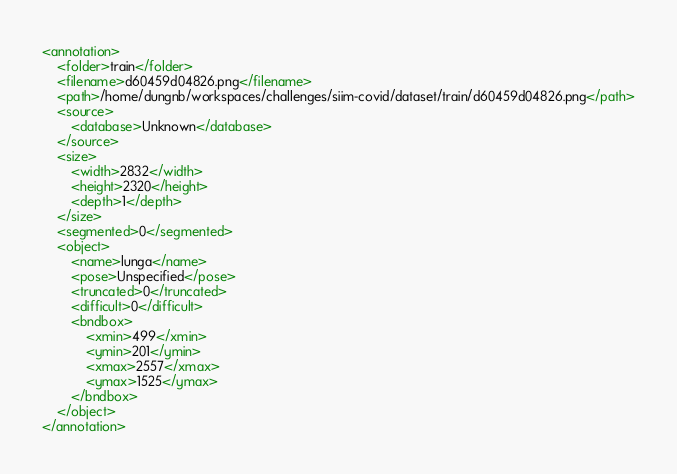Convert code to text. <code><loc_0><loc_0><loc_500><loc_500><_XML_><annotation>
	<folder>train</folder>
	<filename>d60459d04826.png</filename>
	<path>/home/dungnb/workspaces/challenges/siim-covid/dataset/train/d60459d04826.png</path>
	<source>
		<database>Unknown</database>
	</source>
	<size>
		<width>2832</width>
		<height>2320</height>
		<depth>1</depth>
	</size>
	<segmented>0</segmented>
	<object>
		<name>lunga</name>
		<pose>Unspecified</pose>
		<truncated>0</truncated>
		<difficult>0</difficult>
		<bndbox>
			<xmin>499</xmin>
			<ymin>201</ymin>
			<xmax>2557</xmax>
			<ymax>1525</ymax>
		</bndbox>
	</object>
</annotation>
</code> 